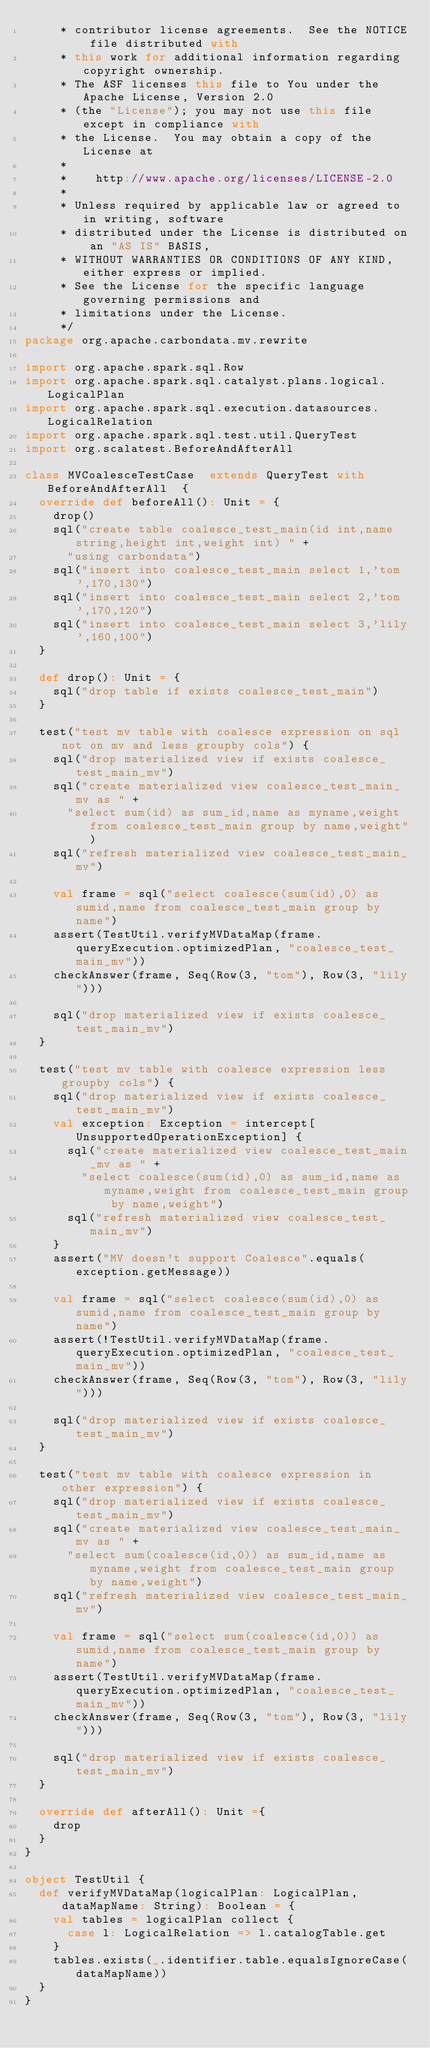Convert code to text. <code><loc_0><loc_0><loc_500><loc_500><_Scala_>	 * contributor license agreements.  See the NOTICE file distributed with
	 * this work for additional information regarding copyright ownership.
	 * The ASF licenses this file to You under the Apache License, Version 2.0
	 * (the "License"); you may not use this file except in compliance with
	 * the License.  You may obtain a copy of the License at
	 *
	 *    http://www.apache.org/licenses/LICENSE-2.0
	 *
	 * Unless required by applicable law or agreed to in writing, software
	 * distributed under the License is distributed on an "AS IS" BASIS,
	 * WITHOUT WARRANTIES OR CONDITIONS OF ANY KIND, either express or implied.
	 * See the License for the specific language governing permissions and
	 * limitations under the License.
	 */
package org.apache.carbondata.mv.rewrite

import org.apache.spark.sql.Row
import org.apache.spark.sql.catalyst.plans.logical.LogicalPlan
import org.apache.spark.sql.execution.datasources.LogicalRelation
import org.apache.spark.sql.test.util.QueryTest
import org.scalatest.BeforeAndAfterAll

class MVCoalesceTestCase  extends QueryTest with BeforeAndAfterAll  {
  override def beforeAll(): Unit = {
    drop()
    sql("create table coalesce_test_main(id int,name string,height int,weight int) " +
      "using carbondata")
    sql("insert into coalesce_test_main select 1,'tom',170,130")
    sql("insert into coalesce_test_main select 2,'tom',170,120")
    sql("insert into coalesce_test_main select 3,'lily',160,100")
  }

  def drop(): Unit = {
    sql("drop table if exists coalesce_test_main")
  }

  test("test mv table with coalesce expression on sql not on mv and less groupby cols") {
    sql("drop materialized view if exists coalesce_test_main_mv")
    sql("create materialized view coalesce_test_main_mv as " +
      "select sum(id) as sum_id,name as myname,weight from coalesce_test_main group by name,weight")
    sql("refresh materialized view coalesce_test_main_mv")

    val frame = sql("select coalesce(sum(id),0) as sumid,name from coalesce_test_main group by name")
    assert(TestUtil.verifyMVDataMap(frame.queryExecution.optimizedPlan, "coalesce_test_main_mv"))
    checkAnswer(frame, Seq(Row(3, "tom"), Row(3, "lily")))

    sql("drop materialized view if exists coalesce_test_main_mv")
  }

  test("test mv table with coalesce expression less groupby cols") {
    sql("drop materialized view if exists coalesce_test_main_mv")
    val exception: Exception = intercept[UnsupportedOperationException] {
      sql("create materialized view coalesce_test_main_mv as " +
        "select coalesce(sum(id),0) as sum_id,name as myname,weight from coalesce_test_main group by name,weight")
      sql("refresh materialized view coalesce_test_main_mv")
    }
    assert("MV doesn't support Coalesce".equals(exception.getMessage))

    val frame = sql("select coalesce(sum(id),0) as sumid,name from coalesce_test_main group by name")
    assert(!TestUtil.verifyMVDataMap(frame.queryExecution.optimizedPlan, "coalesce_test_main_mv"))
    checkAnswer(frame, Seq(Row(3, "tom"), Row(3, "lily")))

    sql("drop materialized view if exists coalesce_test_main_mv")
  }

  test("test mv table with coalesce expression in other expression") {
    sql("drop materialized view if exists coalesce_test_main_mv")
    sql("create materialized view coalesce_test_main_mv as " +
      "select sum(coalesce(id,0)) as sum_id,name as myname,weight from coalesce_test_main group by name,weight")
    sql("refresh materialized view coalesce_test_main_mv")

    val frame = sql("select sum(coalesce(id,0)) as sumid,name from coalesce_test_main group by name")
    assert(TestUtil.verifyMVDataMap(frame.queryExecution.optimizedPlan, "coalesce_test_main_mv"))
    checkAnswer(frame, Seq(Row(3, "tom"), Row(3, "lily")))

    sql("drop materialized view if exists coalesce_test_main_mv")
  }

  override def afterAll(): Unit ={
    drop
  }
}

object TestUtil {
  def verifyMVDataMap(logicalPlan: LogicalPlan, dataMapName: String): Boolean = {
    val tables = logicalPlan collect {
      case l: LogicalRelation => l.catalogTable.get
    }
    tables.exists(_.identifier.table.equalsIgnoreCase(dataMapName))
  }
}</code> 